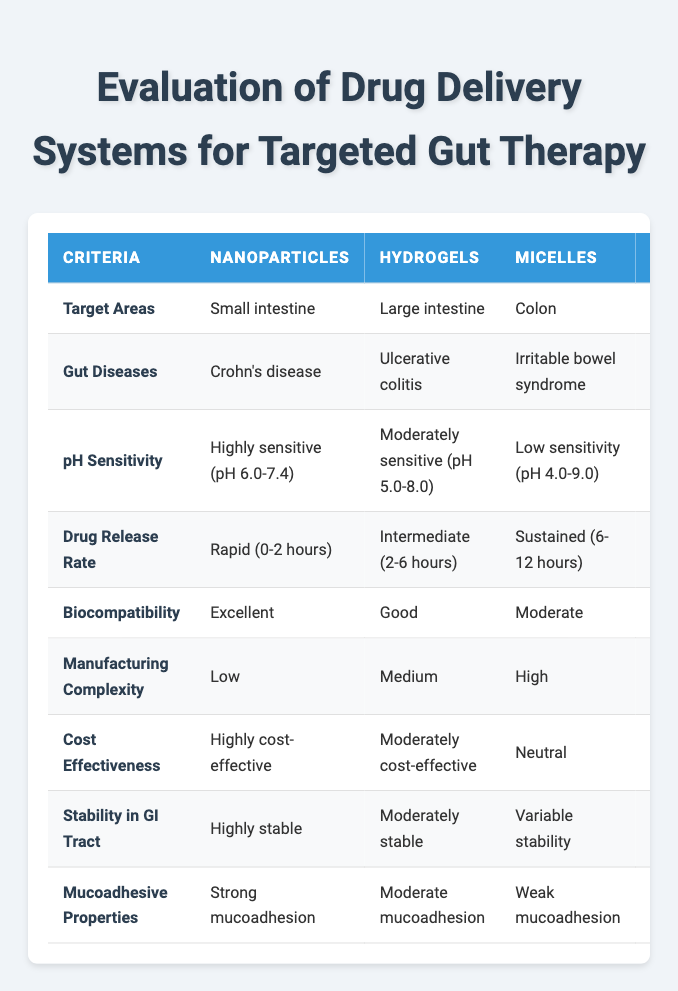What drug delivery system is associated with Crohn's disease? The table shows that the drug delivery system "Nanoparticles" is linked with Crohn's disease under the "Gut Diseases" row.
Answer: Nanoparticles Which drug delivery systems are cost-effective? The table indicates that "Nanoparticles" are highly cost-effective, "Hydrogels" are moderately cost-effective, and "Micelles" are neutral. This implies that the first two are cost-effective to varying degrees.
Answer: Nanoparticles, Hydrogels Is pH-independence a feature of any drug delivery system in this table? The table directly states that "Liposomes" have a pH-independent property under the "pH Sensitivity" row.
Answer: Yes Which drug delivery system has a drug release rate classified as pulsatile? By examining the "Drug Release Rate" row, we find that "Microencapsulation" is the system associated with a pulsatile release rate.
Answer: Microencapsulation What is the average biocompatibility rating of these drug delivery systems? The biocompatibility ratings are Excellent, Good, Moderate, Poor, and Requires further testing. Assigning numerical values (5 to 1), it sums up to 5+4+3+2+1 = 15. Dividing by 5 (the total count), the average is 15/5 = 3, which corresponds to Moderate biocompatibility.
Answer: Moderate What is the most favorable drug delivery system based on stability in the GI tract? "Nanoparticles" have the highest stability rating labeled as "Highly stable," whereas other systems vary in stability. This indicates that nanoparticles are the most favorable option for stability.
Answer: Nanoparticles Is there a relationship between manufacturing complexity and cost-effectiveness among the drug delivery systems? If we analyze the table, "Nanoparticles" have low manufacturing complexity and are highly cost-effective, while "Hydrogels" are associated with moderate complexity and cost-effectiveness. "Micelles" and "Hydrogels" are at a neutral cost level despite differing complexities. This suggests a mixed relationship but not a direct correlation.
Answer: No Which drug delivery system offers tunable mucoadhesion? The table categorizes "Microencapsulation" as having tunable mucoadhesion under the relevant row.
Answer: Microencapsulation Can any drug delivery system be classified as having poor biocompatibility? The table specifies that "Liposomes" have a poor biocompatibility rating.
Answer: Yes 